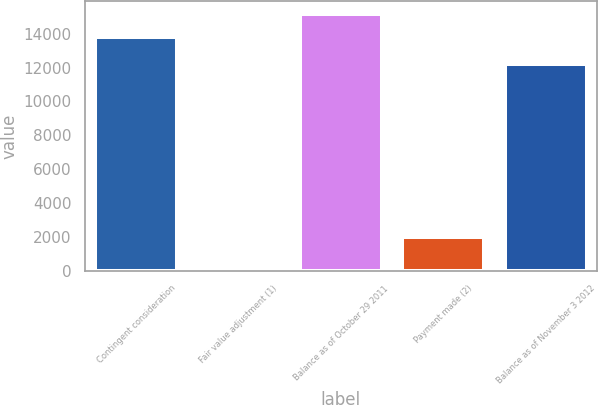<chart> <loc_0><loc_0><loc_500><loc_500><bar_chart><fcel>Contingent consideration<fcel>Fair value adjustment (1)<fcel>Balance as of October 29 2011<fcel>Payment made (2)<fcel>Balance as of November 3 2012<nl><fcel>13790<fcel>183<fcel>15169<fcel>2000<fcel>12219<nl></chart> 